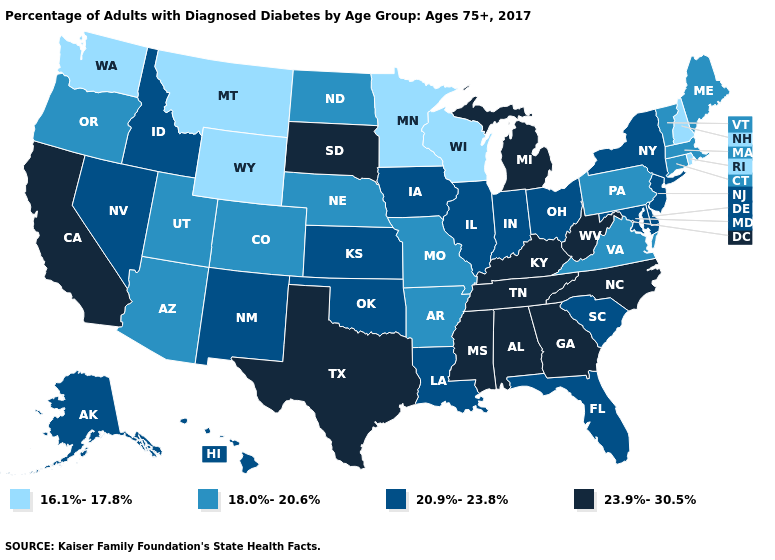What is the value of New York?
Quick response, please. 20.9%-23.8%. Does Oklahoma have the lowest value in the South?
Short answer required. No. What is the lowest value in states that border Nevada?
Keep it brief. 18.0%-20.6%. Among the states that border Louisiana , which have the highest value?
Be succinct. Mississippi, Texas. Does Nevada have a higher value than Colorado?
Answer briefly. Yes. Name the states that have a value in the range 16.1%-17.8%?
Give a very brief answer. Minnesota, Montana, New Hampshire, Rhode Island, Washington, Wisconsin, Wyoming. What is the value of Rhode Island?
Quick response, please. 16.1%-17.8%. What is the highest value in the USA?
Answer briefly. 23.9%-30.5%. Among the states that border Massachusetts , which have the lowest value?
Give a very brief answer. New Hampshire, Rhode Island. What is the lowest value in the MidWest?
Short answer required. 16.1%-17.8%. Does Ohio have a lower value than California?
Quick response, please. Yes. Name the states that have a value in the range 18.0%-20.6%?
Answer briefly. Arizona, Arkansas, Colorado, Connecticut, Maine, Massachusetts, Missouri, Nebraska, North Dakota, Oregon, Pennsylvania, Utah, Vermont, Virginia. What is the value of New Hampshire?
Concise answer only. 16.1%-17.8%. Does Oregon have the lowest value in the West?
Be succinct. No. Among the states that border Wisconsin , which have the highest value?
Answer briefly. Michigan. 